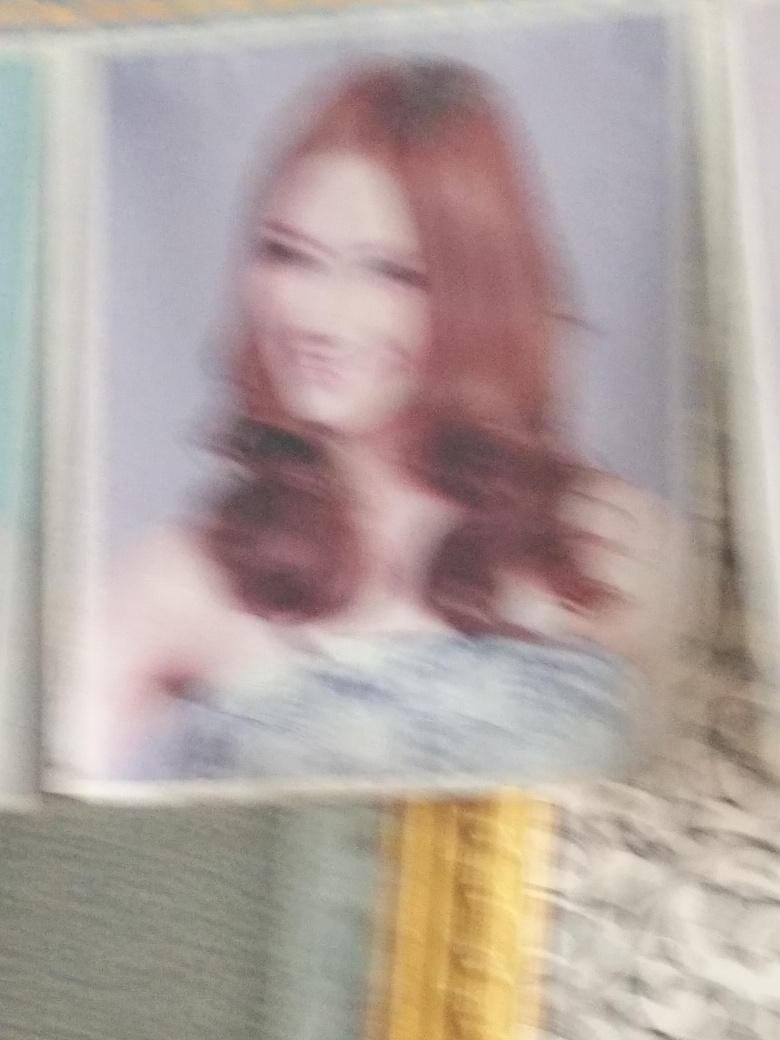What is the overall quality of this image?
A. Average
B. Very poor
C. Good
D. Excellent
Answer with the option's letter from the given choices directly. The overall quality of this image leans towards option B, Very poor. The image is significantly blurred, affecting the viewer's ability to see fine details and detracting from the potential aesthetic qualities. Such a level of blur can often result from camera movement during exposure, an out-of-focus lens, or an extremely low-resolution capture, all of which significantly reduce the clarity and quality of an image. 